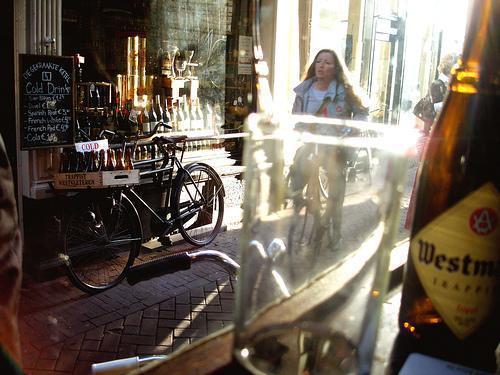This store likely sells what?
Select the accurate response from the four choices given to answer the question.
Options: Books, beer, caviar, marbles. Beer. 